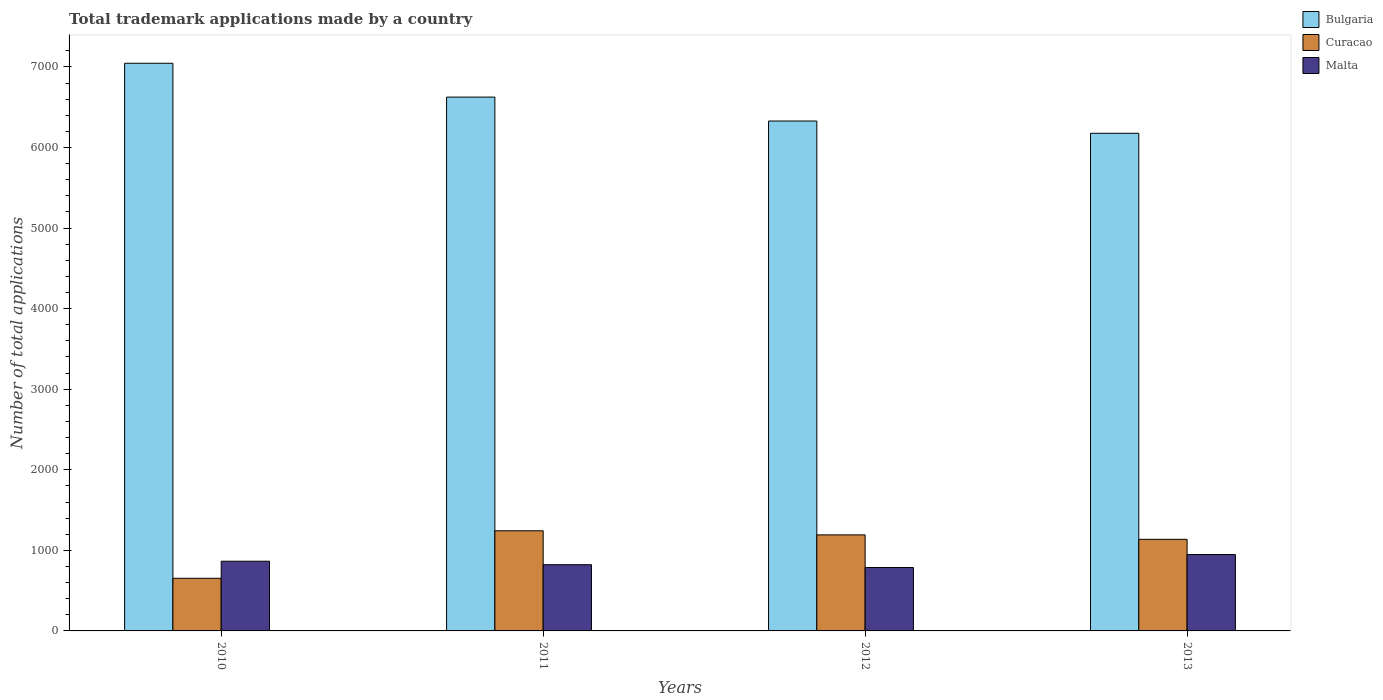How many bars are there on the 4th tick from the right?
Offer a terse response. 3. What is the number of applications made by in Malta in 2011?
Provide a short and direct response. 822. Across all years, what is the maximum number of applications made by in Curacao?
Offer a terse response. 1243. Across all years, what is the minimum number of applications made by in Curacao?
Keep it short and to the point. 653. In which year was the number of applications made by in Malta maximum?
Your answer should be compact. 2013. What is the total number of applications made by in Bulgaria in the graph?
Ensure brevity in your answer.  2.62e+04. What is the difference between the number of applications made by in Malta in 2011 and that in 2013?
Provide a short and direct response. -126. What is the difference between the number of applications made by in Bulgaria in 2012 and the number of applications made by in Malta in 2013?
Make the answer very short. 5381. What is the average number of applications made by in Curacao per year?
Keep it short and to the point. 1056.25. In the year 2011, what is the difference between the number of applications made by in Malta and number of applications made by in Bulgaria?
Your answer should be very brief. -5804. What is the ratio of the number of applications made by in Curacao in 2010 to that in 2013?
Your response must be concise. 0.57. Is the number of applications made by in Curacao in 2012 less than that in 2013?
Make the answer very short. No. What is the difference between the highest and the second highest number of applications made by in Bulgaria?
Your answer should be compact. 420. What is the difference between the highest and the lowest number of applications made by in Malta?
Offer a terse response. 161. Is the sum of the number of applications made by in Curacao in 2010 and 2013 greater than the maximum number of applications made by in Malta across all years?
Provide a short and direct response. Yes. What does the 2nd bar from the left in 2011 represents?
Your answer should be compact. Curacao. What does the 3rd bar from the right in 2012 represents?
Your answer should be compact. Bulgaria. Is it the case that in every year, the sum of the number of applications made by in Curacao and number of applications made by in Malta is greater than the number of applications made by in Bulgaria?
Your answer should be very brief. No. Are all the bars in the graph horizontal?
Your answer should be very brief. No. Are the values on the major ticks of Y-axis written in scientific E-notation?
Your answer should be very brief. No. Does the graph contain any zero values?
Your answer should be very brief. No. Does the graph contain grids?
Ensure brevity in your answer.  No. Where does the legend appear in the graph?
Provide a short and direct response. Top right. How many legend labels are there?
Your answer should be very brief. 3. What is the title of the graph?
Provide a succinct answer. Total trademark applications made by a country. What is the label or title of the Y-axis?
Your response must be concise. Number of total applications. What is the Number of total applications in Bulgaria in 2010?
Provide a succinct answer. 7046. What is the Number of total applications in Curacao in 2010?
Your answer should be very brief. 653. What is the Number of total applications in Malta in 2010?
Provide a short and direct response. 865. What is the Number of total applications of Bulgaria in 2011?
Provide a succinct answer. 6626. What is the Number of total applications of Curacao in 2011?
Offer a very short reply. 1243. What is the Number of total applications in Malta in 2011?
Provide a short and direct response. 822. What is the Number of total applications of Bulgaria in 2012?
Give a very brief answer. 6329. What is the Number of total applications of Curacao in 2012?
Your answer should be very brief. 1192. What is the Number of total applications of Malta in 2012?
Keep it short and to the point. 787. What is the Number of total applications of Bulgaria in 2013?
Offer a terse response. 6177. What is the Number of total applications in Curacao in 2013?
Ensure brevity in your answer.  1137. What is the Number of total applications of Malta in 2013?
Give a very brief answer. 948. Across all years, what is the maximum Number of total applications in Bulgaria?
Make the answer very short. 7046. Across all years, what is the maximum Number of total applications in Curacao?
Your answer should be compact. 1243. Across all years, what is the maximum Number of total applications of Malta?
Provide a short and direct response. 948. Across all years, what is the minimum Number of total applications in Bulgaria?
Provide a short and direct response. 6177. Across all years, what is the minimum Number of total applications of Curacao?
Provide a short and direct response. 653. Across all years, what is the minimum Number of total applications of Malta?
Provide a succinct answer. 787. What is the total Number of total applications of Bulgaria in the graph?
Keep it short and to the point. 2.62e+04. What is the total Number of total applications in Curacao in the graph?
Your answer should be compact. 4225. What is the total Number of total applications of Malta in the graph?
Give a very brief answer. 3422. What is the difference between the Number of total applications of Bulgaria in 2010 and that in 2011?
Offer a very short reply. 420. What is the difference between the Number of total applications of Curacao in 2010 and that in 2011?
Make the answer very short. -590. What is the difference between the Number of total applications of Malta in 2010 and that in 2011?
Ensure brevity in your answer.  43. What is the difference between the Number of total applications in Bulgaria in 2010 and that in 2012?
Provide a succinct answer. 717. What is the difference between the Number of total applications in Curacao in 2010 and that in 2012?
Provide a short and direct response. -539. What is the difference between the Number of total applications of Bulgaria in 2010 and that in 2013?
Make the answer very short. 869. What is the difference between the Number of total applications of Curacao in 2010 and that in 2013?
Provide a succinct answer. -484. What is the difference between the Number of total applications in Malta in 2010 and that in 2013?
Your answer should be very brief. -83. What is the difference between the Number of total applications of Bulgaria in 2011 and that in 2012?
Provide a succinct answer. 297. What is the difference between the Number of total applications of Malta in 2011 and that in 2012?
Offer a very short reply. 35. What is the difference between the Number of total applications of Bulgaria in 2011 and that in 2013?
Make the answer very short. 449. What is the difference between the Number of total applications in Curacao in 2011 and that in 2013?
Make the answer very short. 106. What is the difference between the Number of total applications of Malta in 2011 and that in 2013?
Keep it short and to the point. -126. What is the difference between the Number of total applications in Bulgaria in 2012 and that in 2013?
Your response must be concise. 152. What is the difference between the Number of total applications in Malta in 2012 and that in 2013?
Your response must be concise. -161. What is the difference between the Number of total applications of Bulgaria in 2010 and the Number of total applications of Curacao in 2011?
Provide a short and direct response. 5803. What is the difference between the Number of total applications in Bulgaria in 2010 and the Number of total applications in Malta in 2011?
Ensure brevity in your answer.  6224. What is the difference between the Number of total applications in Curacao in 2010 and the Number of total applications in Malta in 2011?
Keep it short and to the point. -169. What is the difference between the Number of total applications of Bulgaria in 2010 and the Number of total applications of Curacao in 2012?
Your response must be concise. 5854. What is the difference between the Number of total applications of Bulgaria in 2010 and the Number of total applications of Malta in 2012?
Your response must be concise. 6259. What is the difference between the Number of total applications in Curacao in 2010 and the Number of total applications in Malta in 2012?
Your response must be concise. -134. What is the difference between the Number of total applications in Bulgaria in 2010 and the Number of total applications in Curacao in 2013?
Provide a short and direct response. 5909. What is the difference between the Number of total applications of Bulgaria in 2010 and the Number of total applications of Malta in 2013?
Your answer should be very brief. 6098. What is the difference between the Number of total applications of Curacao in 2010 and the Number of total applications of Malta in 2013?
Keep it short and to the point. -295. What is the difference between the Number of total applications in Bulgaria in 2011 and the Number of total applications in Curacao in 2012?
Your response must be concise. 5434. What is the difference between the Number of total applications of Bulgaria in 2011 and the Number of total applications of Malta in 2012?
Offer a terse response. 5839. What is the difference between the Number of total applications of Curacao in 2011 and the Number of total applications of Malta in 2012?
Keep it short and to the point. 456. What is the difference between the Number of total applications of Bulgaria in 2011 and the Number of total applications of Curacao in 2013?
Your answer should be compact. 5489. What is the difference between the Number of total applications in Bulgaria in 2011 and the Number of total applications in Malta in 2013?
Make the answer very short. 5678. What is the difference between the Number of total applications of Curacao in 2011 and the Number of total applications of Malta in 2013?
Offer a terse response. 295. What is the difference between the Number of total applications of Bulgaria in 2012 and the Number of total applications of Curacao in 2013?
Provide a short and direct response. 5192. What is the difference between the Number of total applications of Bulgaria in 2012 and the Number of total applications of Malta in 2013?
Make the answer very short. 5381. What is the difference between the Number of total applications of Curacao in 2012 and the Number of total applications of Malta in 2013?
Ensure brevity in your answer.  244. What is the average Number of total applications of Bulgaria per year?
Give a very brief answer. 6544.5. What is the average Number of total applications of Curacao per year?
Provide a succinct answer. 1056.25. What is the average Number of total applications of Malta per year?
Keep it short and to the point. 855.5. In the year 2010, what is the difference between the Number of total applications in Bulgaria and Number of total applications in Curacao?
Your answer should be very brief. 6393. In the year 2010, what is the difference between the Number of total applications of Bulgaria and Number of total applications of Malta?
Your response must be concise. 6181. In the year 2010, what is the difference between the Number of total applications of Curacao and Number of total applications of Malta?
Offer a very short reply. -212. In the year 2011, what is the difference between the Number of total applications of Bulgaria and Number of total applications of Curacao?
Your answer should be very brief. 5383. In the year 2011, what is the difference between the Number of total applications in Bulgaria and Number of total applications in Malta?
Keep it short and to the point. 5804. In the year 2011, what is the difference between the Number of total applications of Curacao and Number of total applications of Malta?
Keep it short and to the point. 421. In the year 2012, what is the difference between the Number of total applications in Bulgaria and Number of total applications in Curacao?
Your answer should be very brief. 5137. In the year 2012, what is the difference between the Number of total applications in Bulgaria and Number of total applications in Malta?
Make the answer very short. 5542. In the year 2012, what is the difference between the Number of total applications of Curacao and Number of total applications of Malta?
Your answer should be compact. 405. In the year 2013, what is the difference between the Number of total applications of Bulgaria and Number of total applications of Curacao?
Your response must be concise. 5040. In the year 2013, what is the difference between the Number of total applications of Bulgaria and Number of total applications of Malta?
Your answer should be very brief. 5229. In the year 2013, what is the difference between the Number of total applications of Curacao and Number of total applications of Malta?
Provide a succinct answer. 189. What is the ratio of the Number of total applications of Bulgaria in 2010 to that in 2011?
Your answer should be compact. 1.06. What is the ratio of the Number of total applications of Curacao in 2010 to that in 2011?
Your answer should be compact. 0.53. What is the ratio of the Number of total applications in Malta in 2010 to that in 2011?
Keep it short and to the point. 1.05. What is the ratio of the Number of total applications of Bulgaria in 2010 to that in 2012?
Your response must be concise. 1.11. What is the ratio of the Number of total applications of Curacao in 2010 to that in 2012?
Provide a short and direct response. 0.55. What is the ratio of the Number of total applications of Malta in 2010 to that in 2012?
Provide a short and direct response. 1.1. What is the ratio of the Number of total applications of Bulgaria in 2010 to that in 2013?
Provide a succinct answer. 1.14. What is the ratio of the Number of total applications in Curacao in 2010 to that in 2013?
Your response must be concise. 0.57. What is the ratio of the Number of total applications of Malta in 2010 to that in 2013?
Give a very brief answer. 0.91. What is the ratio of the Number of total applications of Bulgaria in 2011 to that in 2012?
Give a very brief answer. 1.05. What is the ratio of the Number of total applications in Curacao in 2011 to that in 2012?
Provide a short and direct response. 1.04. What is the ratio of the Number of total applications of Malta in 2011 to that in 2012?
Your response must be concise. 1.04. What is the ratio of the Number of total applications of Bulgaria in 2011 to that in 2013?
Your answer should be compact. 1.07. What is the ratio of the Number of total applications in Curacao in 2011 to that in 2013?
Make the answer very short. 1.09. What is the ratio of the Number of total applications in Malta in 2011 to that in 2013?
Offer a terse response. 0.87. What is the ratio of the Number of total applications in Bulgaria in 2012 to that in 2013?
Offer a very short reply. 1.02. What is the ratio of the Number of total applications in Curacao in 2012 to that in 2013?
Ensure brevity in your answer.  1.05. What is the ratio of the Number of total applications of Malta in 2012 to that in 2013?
Offer a very short reply. 0.83. What is the difference between the highest and the second highest Number of total applications in Bulgaria?
Offer a terse response. 420. What is the difference between the highest and the second highest Number of total applications of Curacao?
Give a very brief answer. 51. What is the difference between the highest and the lowest Number of total applications of Bulgaria?
Offer a terse response. 869. What is the difference between the highest and the lowest Number of total applications of Curacao?
Your answer should be compact. 590. What is the difference between the highest and the lowest Number of total applications in Malta?
Provide a short and direct response. 161. 